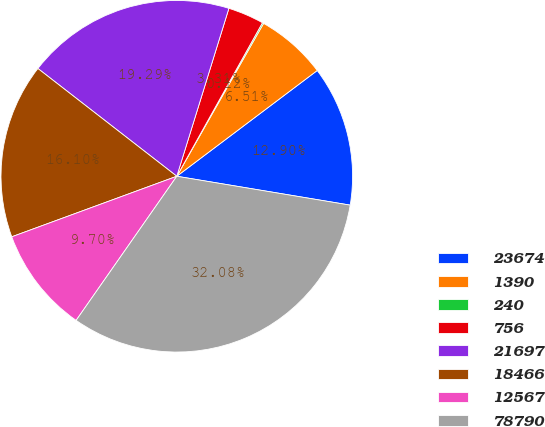Convert chart. <chart><loc_0><loc_0><loc_500><loc_500><pie_chart><fcel>23674<fcel>1390<fcel>240<fcel>756<fcel>21697<fcel>18466<fcel>12567<fcel>78790<nl><fcel>12.9%<fcel>6.51%<fcel>0.12%<fcel>3.31%<fcel>19.29%<fcel>16.1%<fcel>9.7%<fcel>32.08%<nl></chart> 